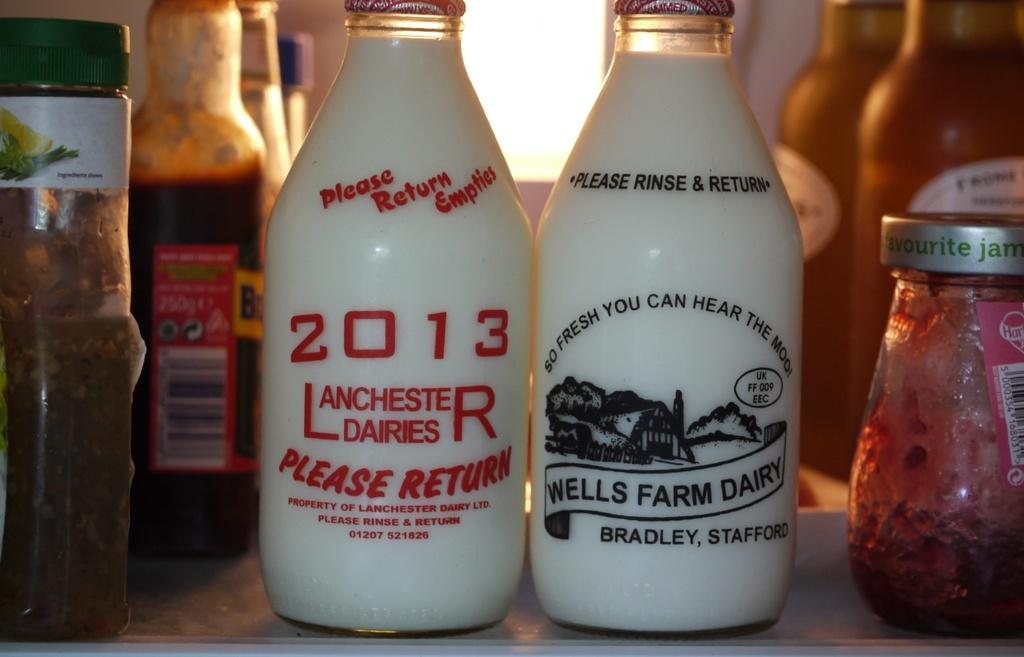<image>
Describe the image concisely. Two glasses of milk sit next to each other, one from wells farm dairy 